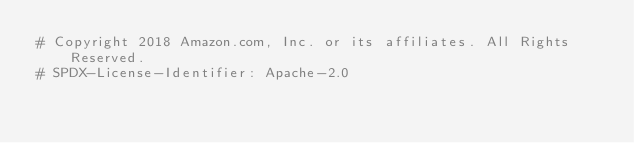<code> <loc_0><loc_0><loc_500><loc_500><_Python_># Copyright 2018 Amazon.com, Inc. or its affiliates. All Rights Reserved.
# SPDX-License-Identifier: Apache-2.0</code> 